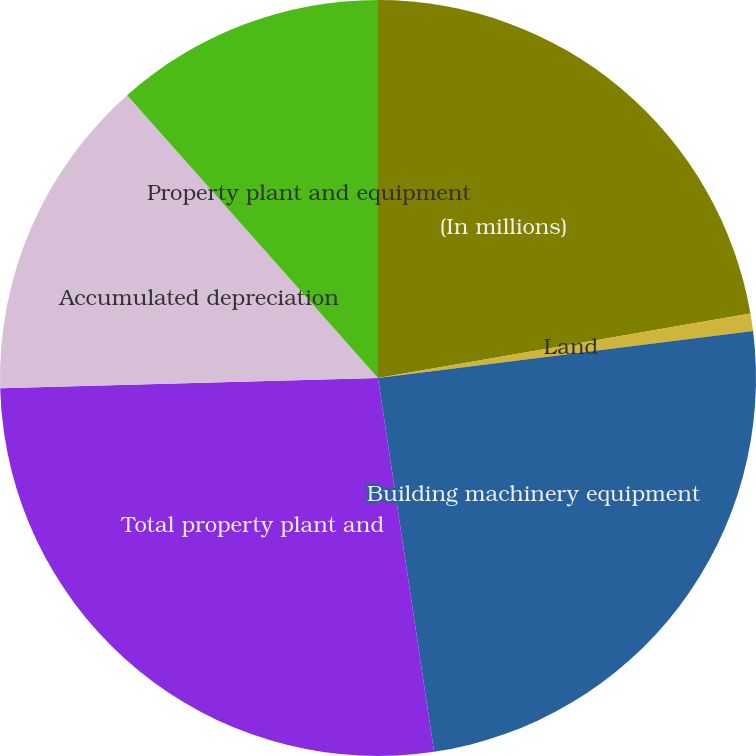Convert chart to OTSL. <chart><loc_0><loc_0><loc_500><loc_500><pie_chart><fcel>(In millions)<fcel>Land<fcel>Building machinery equipment<fcel>Total property plant and<fcel>Accumulated depreciation<fcel>Property plant and equipment<nl><fcel>22.27%<fcel>0.75%<fcel>24.61%<fcel>26.94%<fcel>13.88%<fcel>11.55%<nl></chart> 